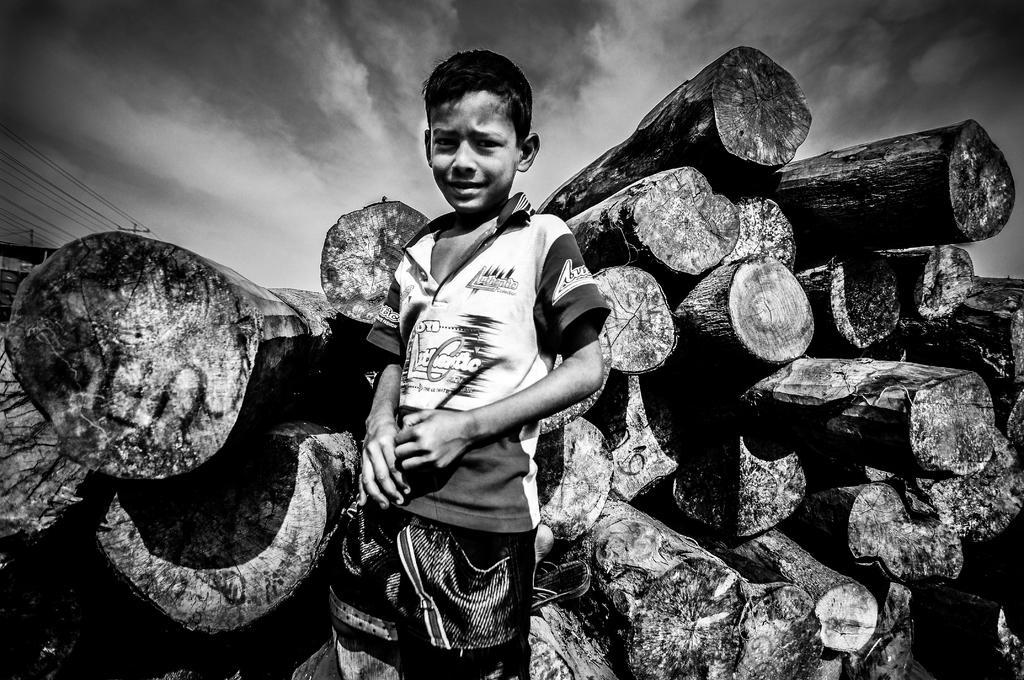Describe this image in one or two sentences. This is a black and white image. In this image we can see a kid, logs of wood and other objects. In the background of the image there are poles and cables. At the top of the image there is the sky. 